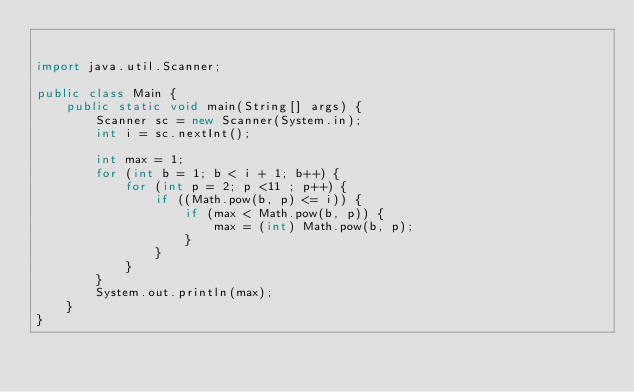Convert code to text. <code><loc_0><loc_0><loc_500><loc_500><_Java_>

import java.util.Scanner;

public class Main {
	public static void main(String[] args) {
		Scanner sc = new Scanner(System.in);
		int i = sc.nextInt();

		int max = 1;
		for (int b = 1; b < i + 1; b++) {
			for (int p = 2; p <11 ; p++) {
				if ((Math.pow(b, p) <= i)) {
					if (max < Math.pow(b, p)) {
						max = (int) Math.pow(b, p);
					}
				}
			}
		}
		System.out.println(max);
	}
}
</code> 